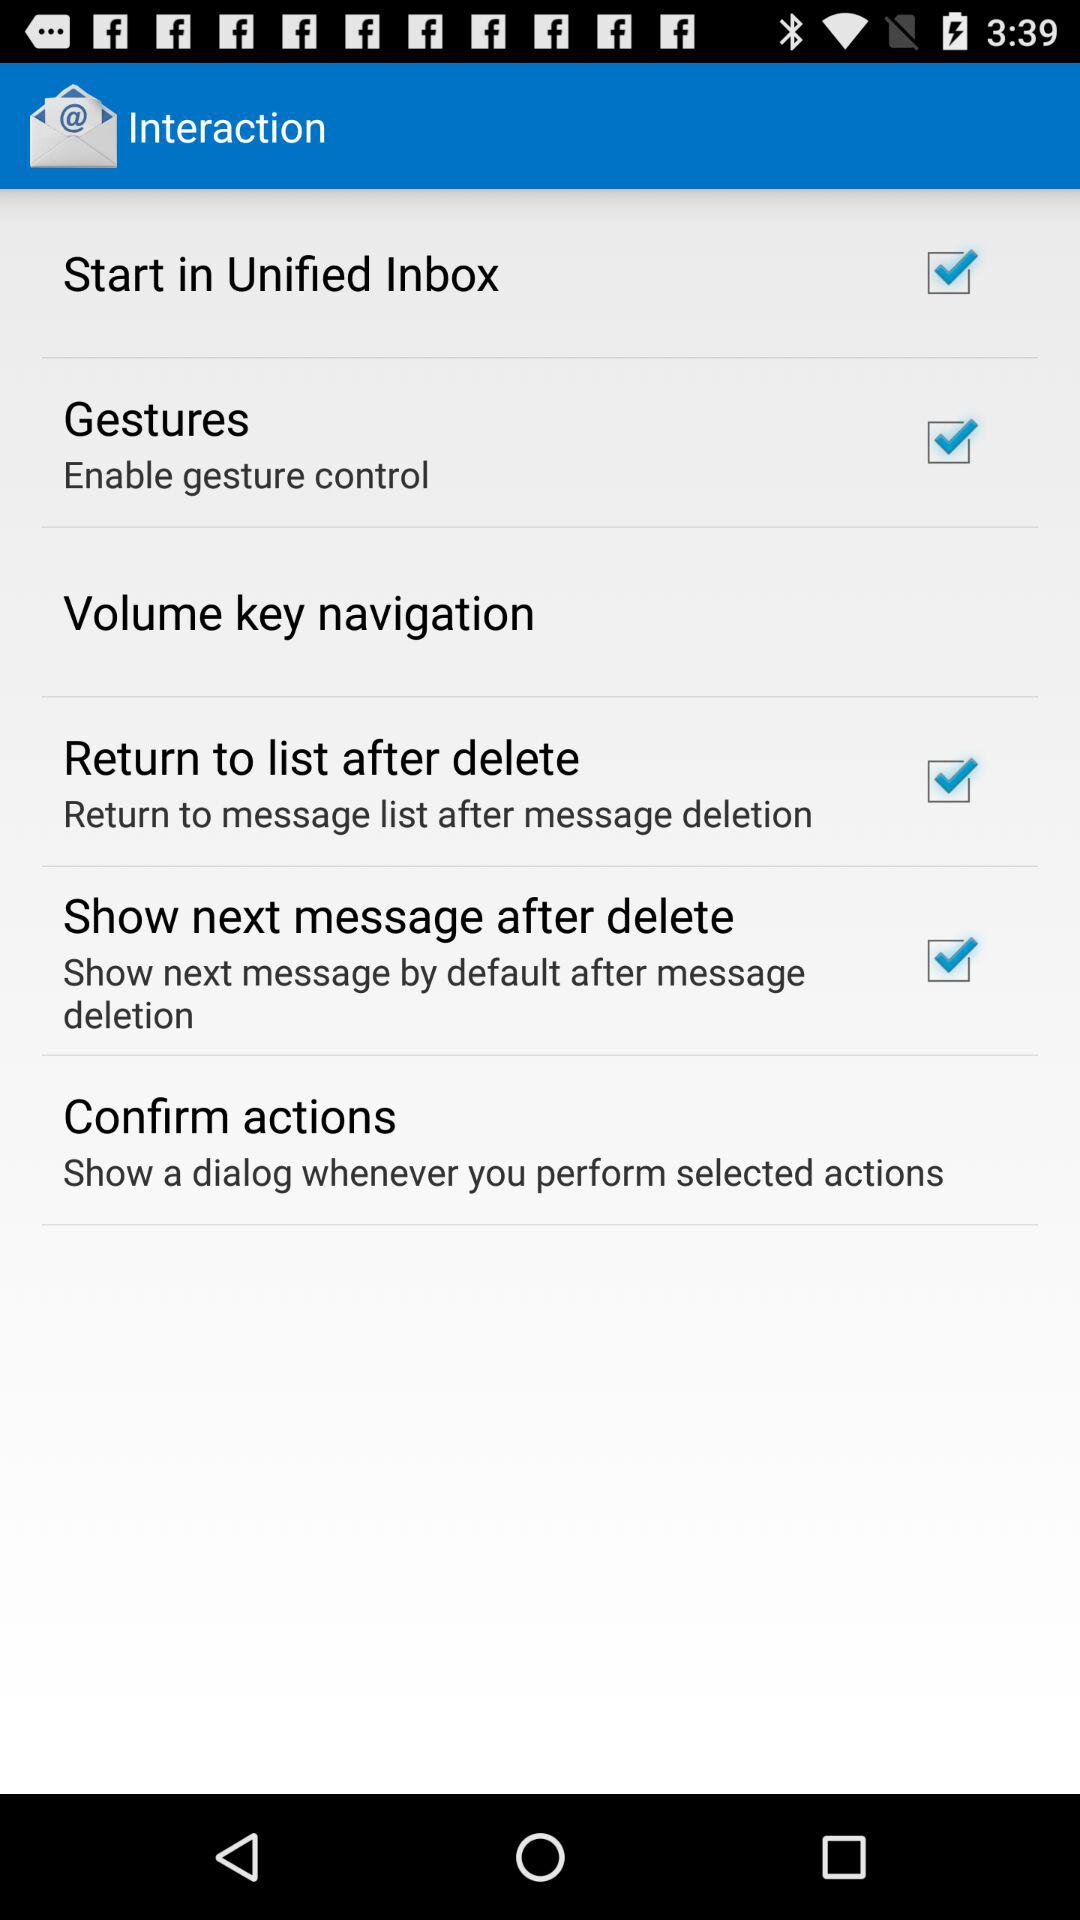What is the status of "Start in Unified Inbox"? The status of "Start in Unified Inbox" is "on". 